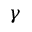Convert formula to latex. <formula><loc_0><loc_0><loc_500><loc_500>\gamma</formula> 